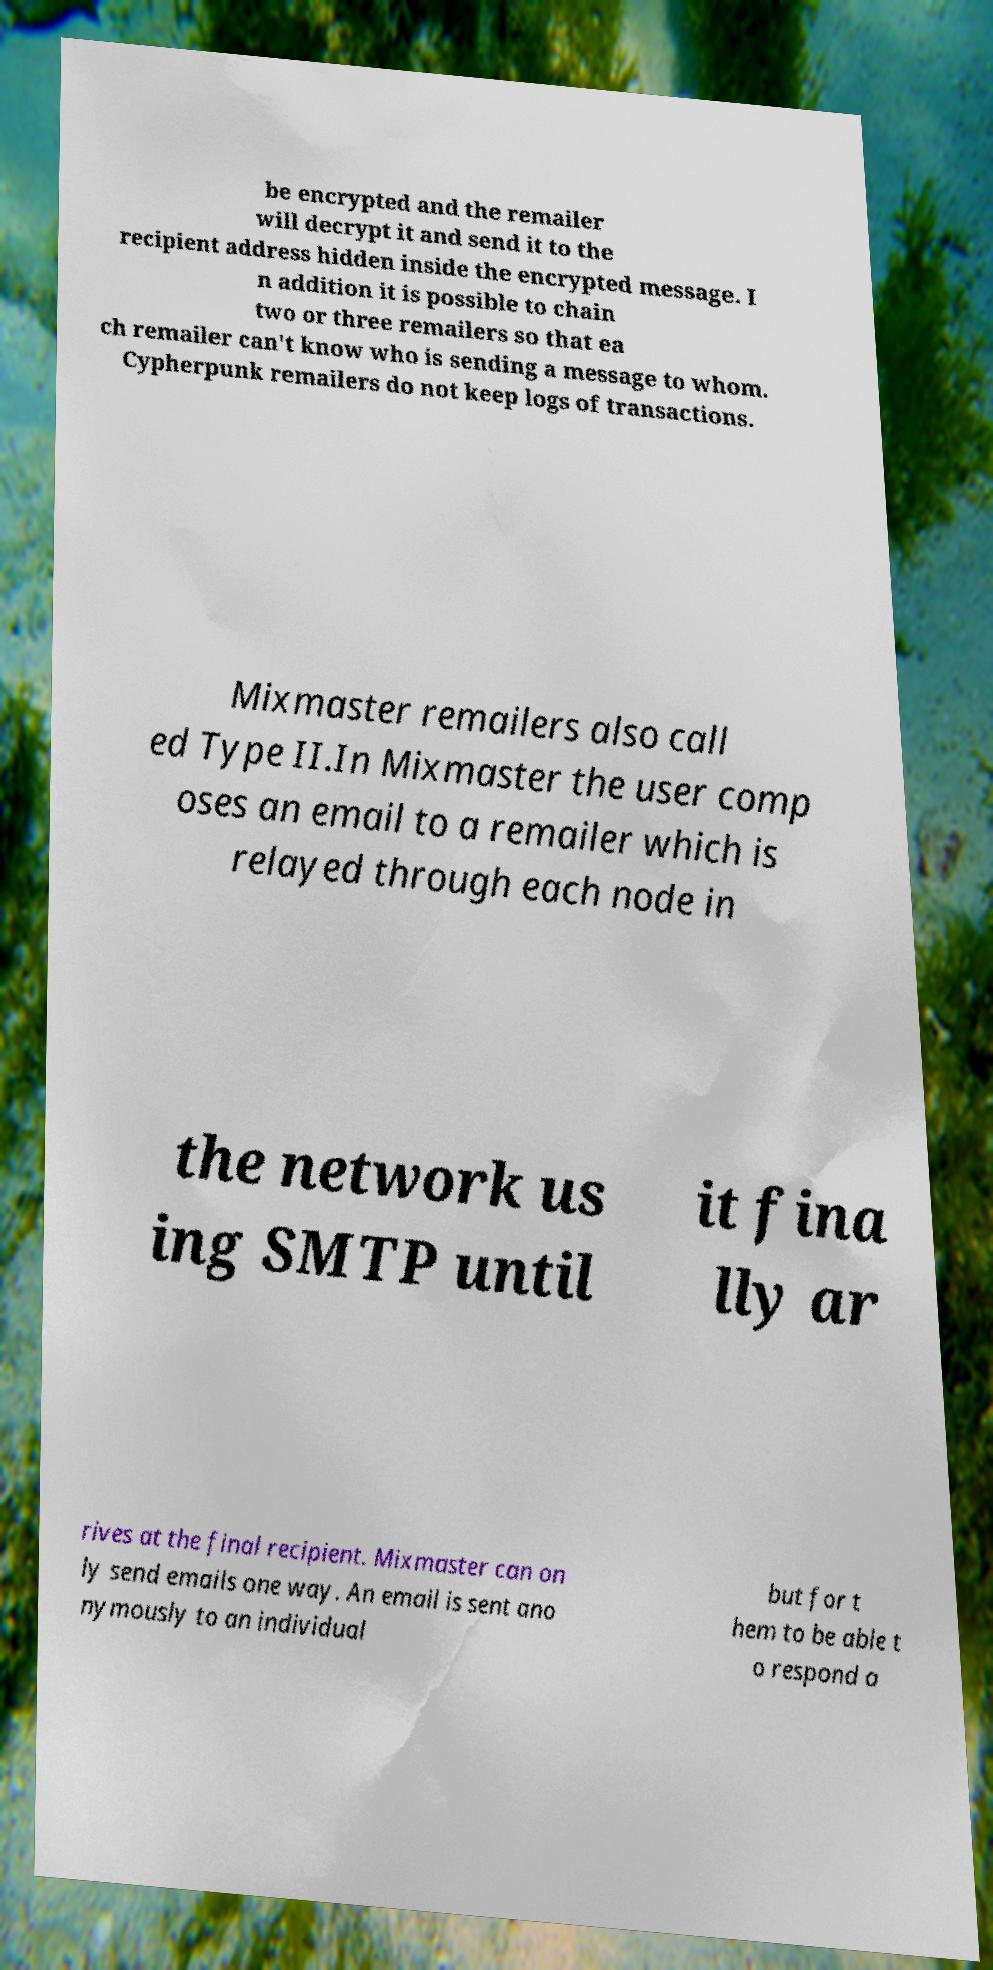I need the written content from this picture converted into text. Can you do that? be encrypted and the remailer will decrypt it and send it to the recipient address hidden inside the encrypted message. I n addition it is possible to chain two or three remailers so that ea ch remailer can't know who is sending a message to whom. Cypherpunk remailers do not keep logs of transactions. Mixmaster remailers also call ed Type II.In Mixmaster the user comp oses an email to a remailer which is relayed through each node in the network us ing SMTP until it fina lly ar rives at the final recipient. Mixmaster can on ly send emails one way. An email is sent ano nymously to an individual but for t hem to be able t o respond a 